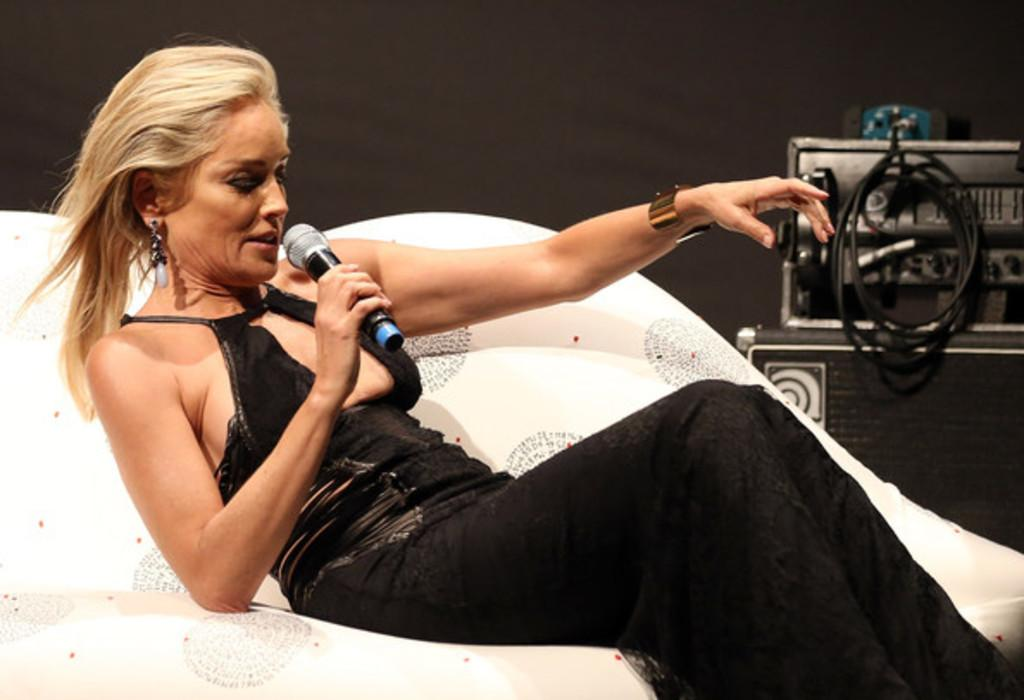Who is the main subject in the image? There is a lady in the image. What is the lady doing in the image? The lady is sitting in the image. What is the lady holding in the image? The lady is holding a microphone in the image. Can you describe the object placed at the rightmost part of the image? Unfortunately, the provided facts do not give any information about the object placed at the rightmost part of the image. What type of chair is the lady sitting on in the image? The provided facts do not mention any chair in the image, so we cannot determine the type of chair the lady is sitting on. Is there a party going on in the image? There is no information about a party in the provided facts, so we cannot determine if there is a party going on in the image. 